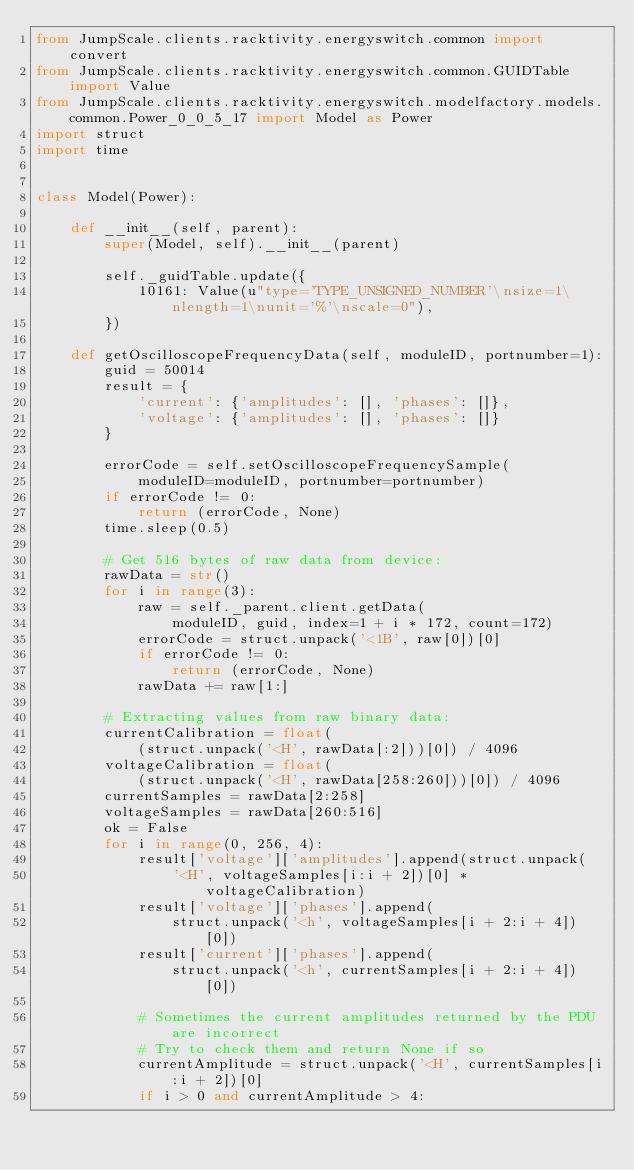Convert code to text. <code><loc_0><loc_0><loc_500><loc_500><_Python_>from JumpScale.clients.racktivity.energyswitch.common import convert
from JumpScale.clients.racktivity.energyswitch.common.GUIDTable import Value
from JumpScale.clients.racktivity.energyswitch.modelfactory.models.common.Power_0_0_5_17 import Model as Power
import struct
import time


class Model(Power):

    def __init__(self, parent):
        super(Model, self).__init__(parent)

        self._guidTable.update({
            10161: Value(u"type='TYPE_UNSIGNED_NUMBER'\nsize=1\nlength=1\nunit='%'\nscale=0"),
        })

    def getOscilloscopeFrequencyData(self, moduleID, portnumber=1):
        guid = 50014
        result = {
            'current': {'amplitudes': [], 'phases': []},
            'voltage': {'amplitudes': [], 'phases': []}
        }

        errorCode = self.setOscilloscopeFrequencySample(
            moduleID=moduleID, portnumber=portnumber)
        if errorCode != 0:
            return (errorCode, None)
        time.sleep(0.5)

        # Get 516 bytes of raw data from device:
        rawData = str()
        for i in range(3):
            raw = self._parent.client.getData(
                moduleID, guid, index=1 + i * 172, count=172)
            errorCode = struct.unpack('<1B', raw[0])[0]
            if errorCode != 0:
                return (errorCode, None)
            rawData += raw[1:]

        # Extracting values from raw binary data:
        currentCalibration = float(
            (struct.unpack('<H', rawData[:2]))[0]) / 4096
        voltageCalibration = float(
            (struct.unpack('<H', rawData[258:260]))[0]) / 4096
        currentSamples = rawData[2:258]
        voltageSamples = rawData[260:516]
        ok = False
        for i in range(0, 256, 4):
            result['voltage']['amplitudes'].append(struct.unpack(
                '<H', voltageSamples[i:i + 2])[0] * voltageCalibration)
            result['voltage']['phases'].append(
                struct.unpack('<h', voltageSamples[i + 2:i + 4])[0])
            result['current']['phases'].append(
                struct.unpack('<h', currentSamples[i + 2:i + 4])[0])

            # Sometimes the current amplitudes returned by the PDU are incorrect
            # Try to check them and return None if so
            currentAmplitude = struct.unpack('<H', currentSamples[i:i + 2])[0]
            if i > 0 and currentAmplitude > 4:</code> 